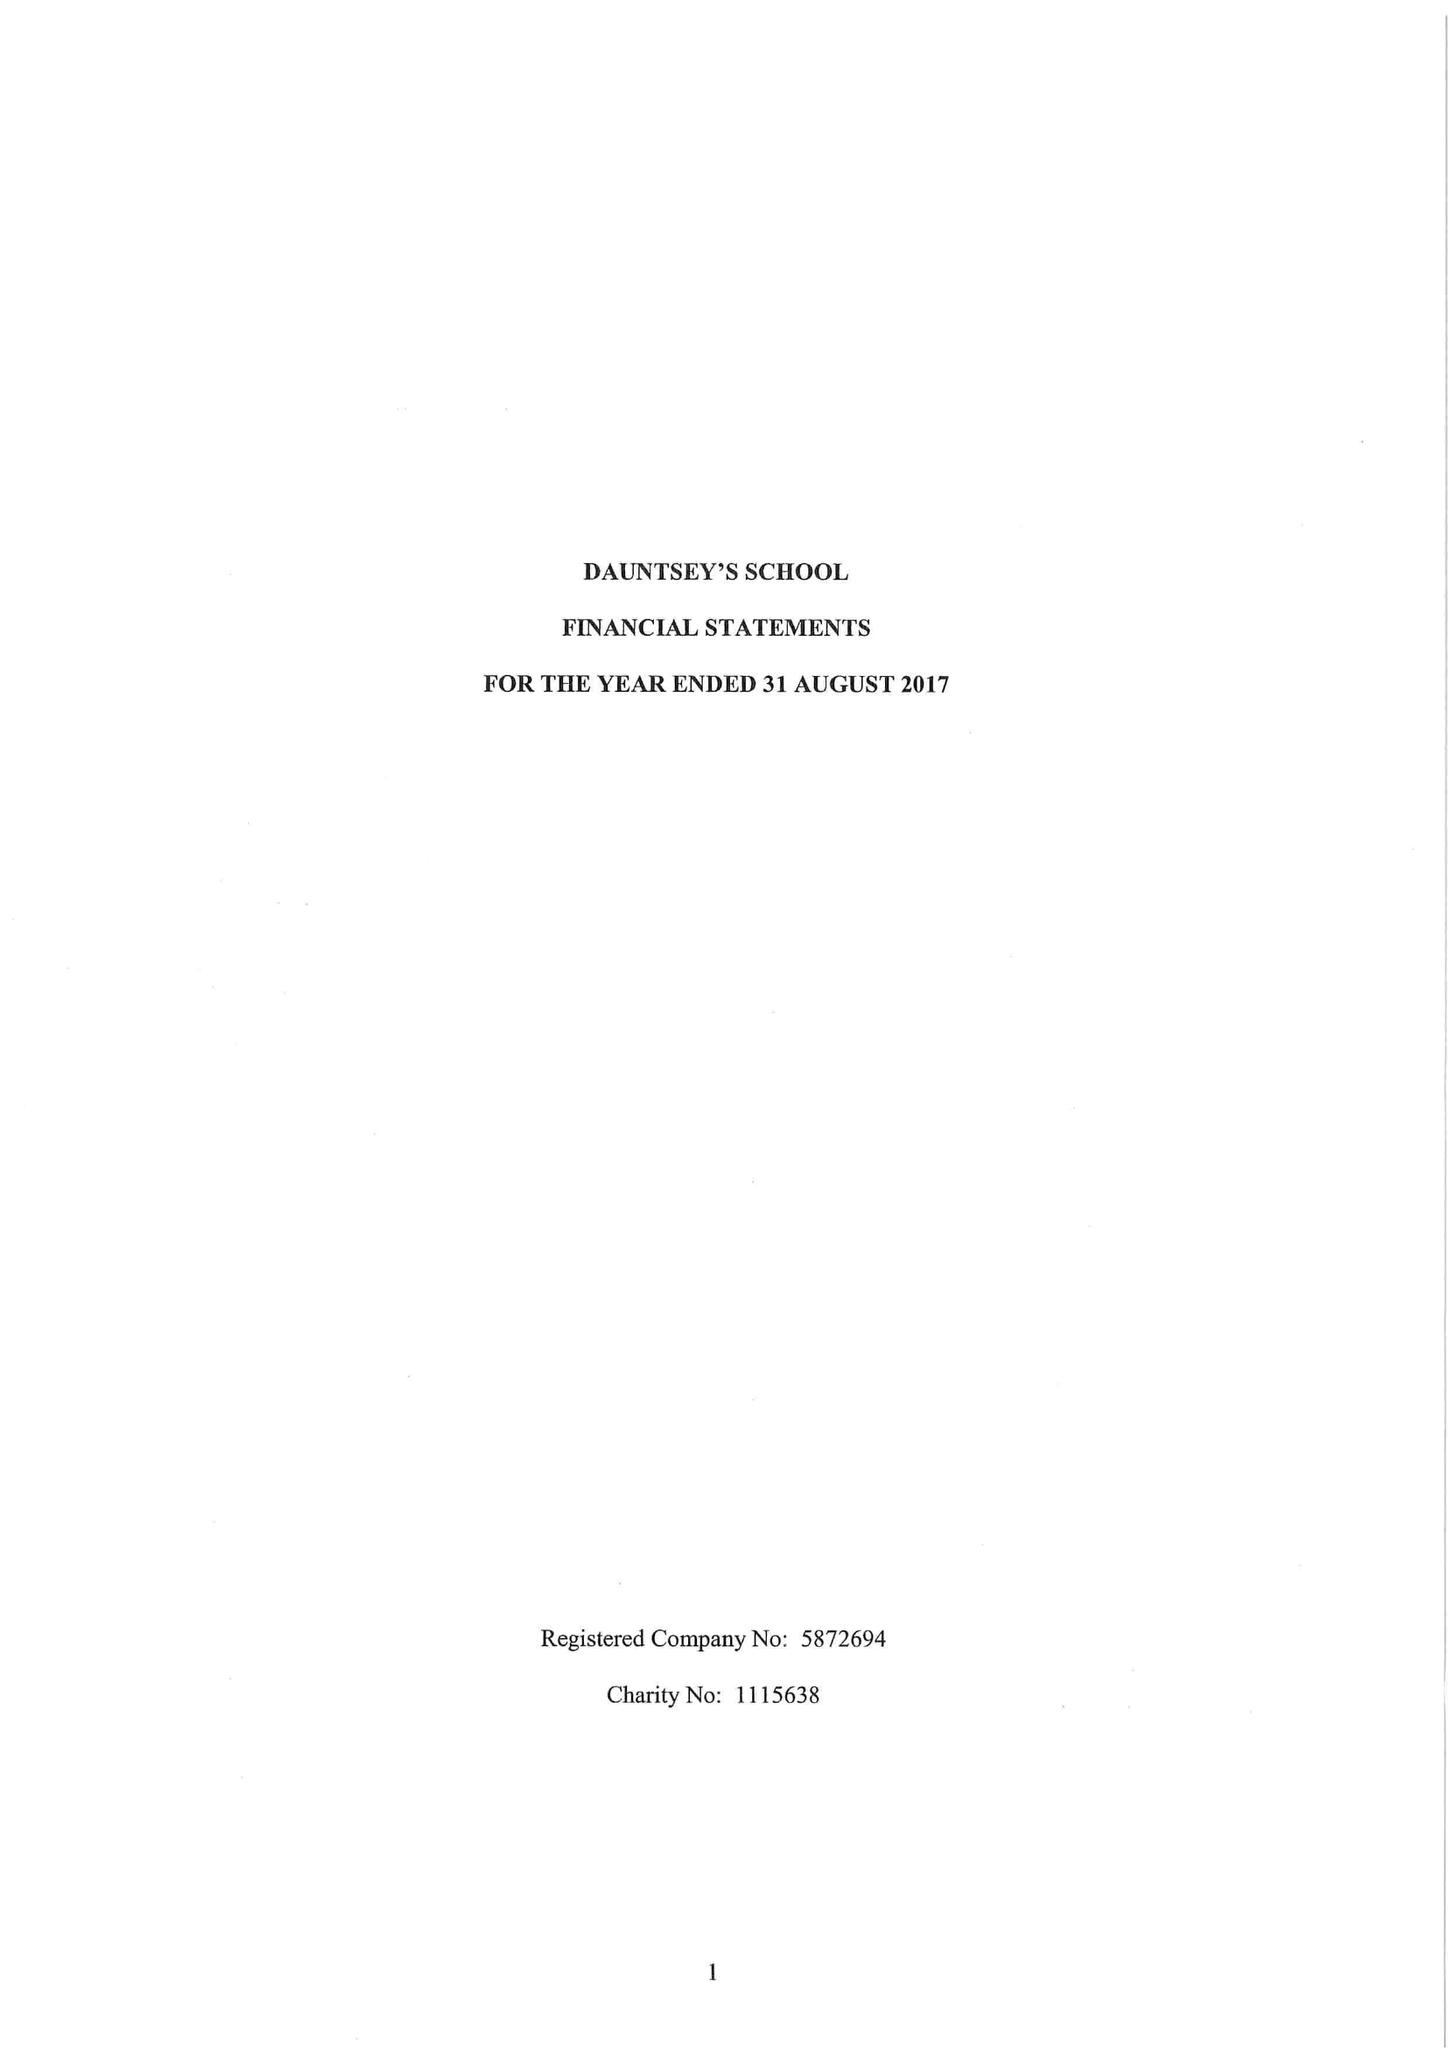What is the value for the spending_annually_in_british_pounds?
Answer the question using a single word or phrase. 17281450.00 